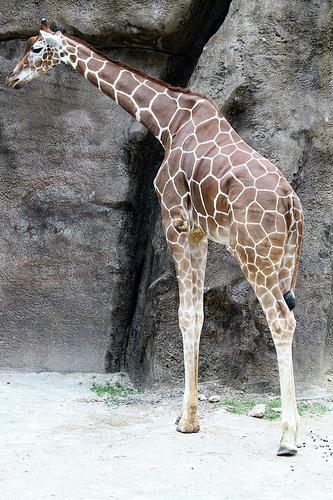Explain the appearance of the giraffe's tail and the hoof of its back foot. The giraffe's tail is thin with a black end, and the hoof of its back foot appears to be brown and sturdy. What are the colors and pattern of the giraffe's fur? The giraffe is brown and white with an interesting pattern of brown spots on its body. What is the dominant feature of the giraffe in the image? The giraffe is very tall with a long neck and brown spots on its body. Describe the positions and features of the giraffe's front and back hooves. The two front hooves of the giraffe are standing by a rock wall, while the back left hoof is seen in the back. They are all sturdy and brown. List some characteristics mentioned about the giraffe's head and neck. The giraffe has a very long neck, black eyes, boney horns on top of its head, and a small patch of brown hair along the neck. Describe the position and appearance of the three rocks in the image. The three rocks are on the ground behind the giraffe's feet and appear to be huge and of various shapes, with some having cracks and gray sides. Describe the background features in the image, particularly the rocks and wall. The background features huge rocks keeping the giraffe enclosed, some with angular edges and notches on the side, and a rock wall with a wide bump and dimpled opening on its surface. How does the giraffe's mouth look in the image? The giraffe's mouth is slightly open with its lips apart. What is the condition of the grass near the giraffe's feet, and what is its color? The grass at the giraffe's feet is sparse, scrubby, and green. 